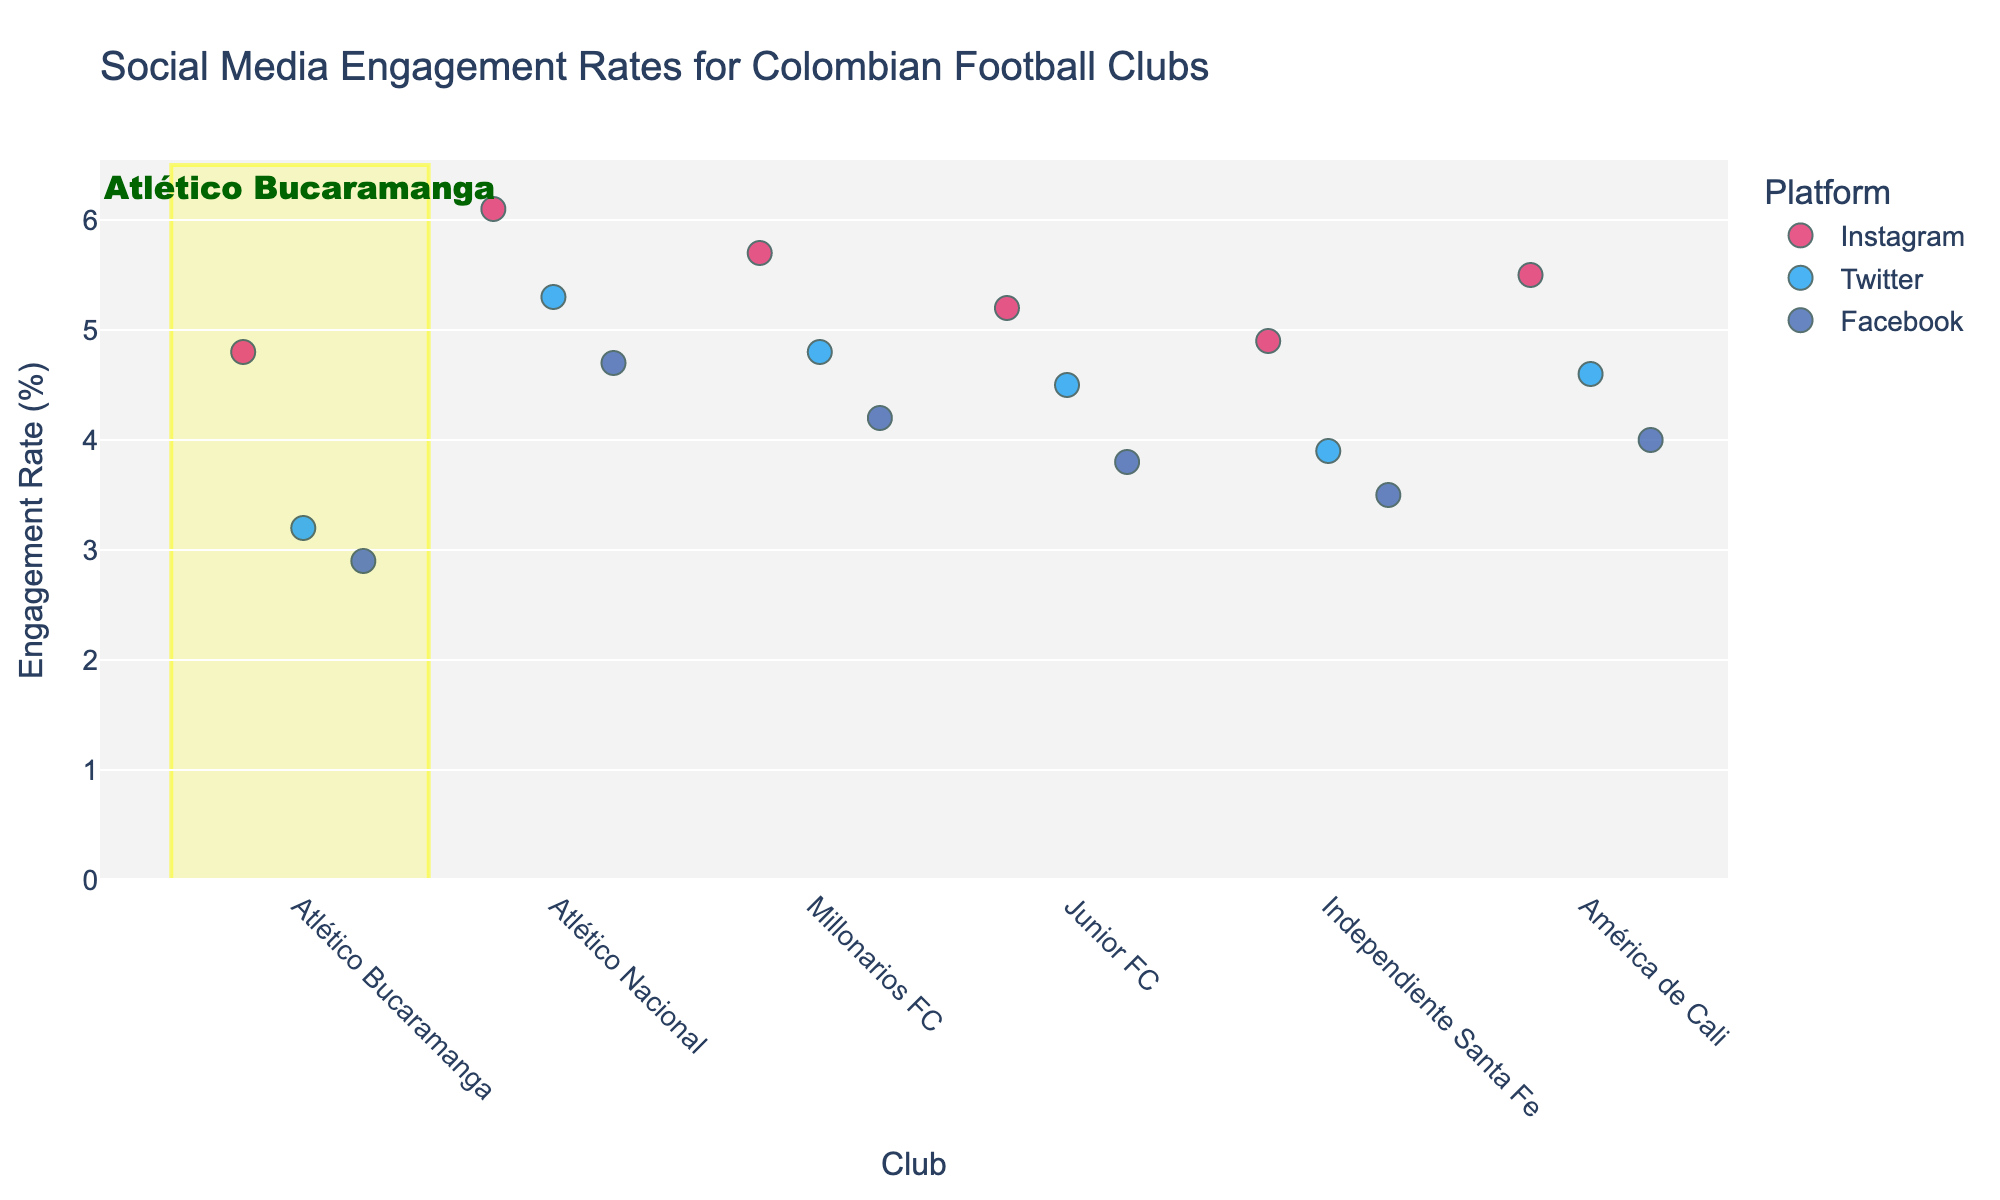what is the title of the plot? The title is located at the top of the plot and provides an overview of the data being visualized.
Answer: Social Media Engagement Rates for Colombian Football Clubs which platform has the highest engagement rate for atlético bucaramanga? By examining the markers within the highlighted rectangle for Atlético Bucaramanga, the marker at the highest position corresponds to Instagram.
Answer: Instagram compare the engagement rate on twitter between atlético nacional and junior fc. For this, locate the markers for both clubs under the Twitter color (light blue) and compare their vertical positions. Atlético Nacional has a higher engagement rate than Junior FC.
Answer: Atlético Nacional how many clubs have higher instagram engagement rates than atlético bucaramanga? Locate the Instagram markers (pink) for Atlético Bucaramanga and count how many are positioned higher than its marker (4.8). The clubs are Atlético Nacional, Millonarios FC, Junior FC, and América de Cali, summing up to 4 clubs.
Answer: 4 what's the average engagement rate on facebook for atlético bucaramanga, millonarios fc, and américa de cali? Find the Facebook markers (dark blue) for the mentioned clubs and add their values: 2.9 (Atlético Bucaramanga) + 4.2 (Millonarios FC) + 4.0 (América de Cali). Divide the sum (11.1) by 3 to get the average.
Answer: 3.7 which club has the lowest engagement rate on any platform? By inspecting all the markers, the lowest one belongs to Atlético Bucaramanga on Facebook, with an engagement rate of 2.9.
Answer: Atlético Bucaramanga how many platforms have an engagement rate above 5.0 for millonarios fc? Check the markers for Millonarios FC and count how many are above the 5.0 mark. The Instagram rate is 5.7, and the Twitter rate is 4.8, so only 1 platform (Instagram) exceeds 5.0.
Answer: 1 which clubs have identical engagement rates on instagram? Compare the Instagram markers' positions and values. Atlético Bucaramanga (4.8) and Independiente Santa Fe (4.9) are close but not identical. No clubs have matching markers; thus, no identical rates exist.
Answer: None what is the median engagement rate on facebook for all clubs? List all the Facebook rates: 2.9, 4.7, 4.2, 3.8, 3.5, 4.0. Sort them: 2.9, 3.5, 3.8, 4.0, 4.2, 4.7. The median is the average of the middle values (3.8 and 4.0), which is 3.9.
Answer: 3.9 